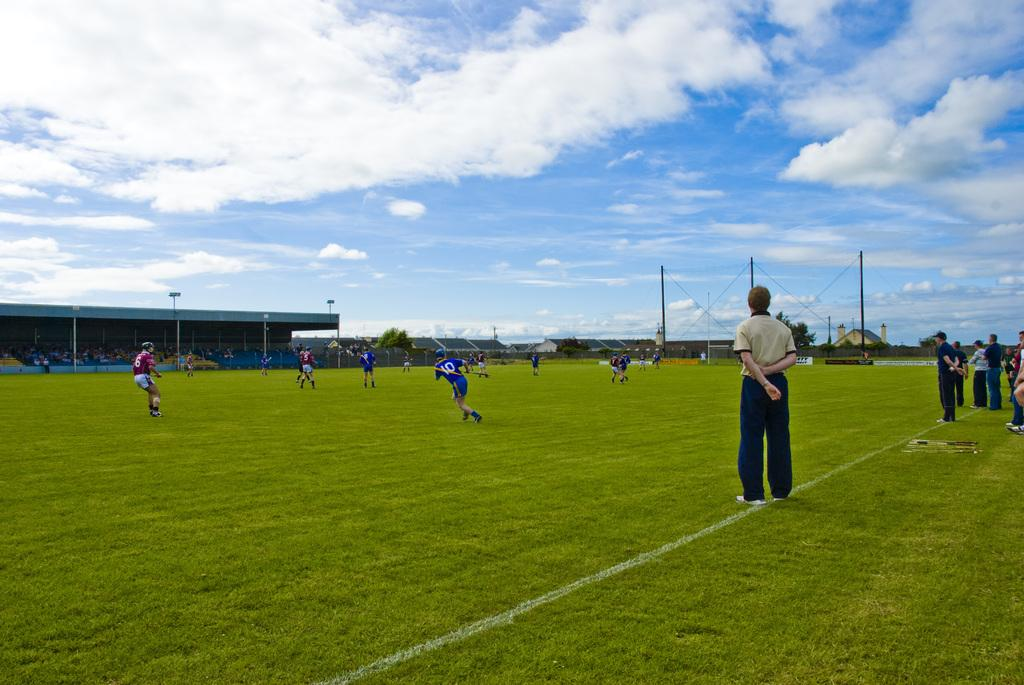What activity are the people in the image engaged in? People are playing a sport in the image. What type of surface is visible at the bottom of the image? There is grass at the bottom of the image. Can you describe the position of the person in the image? There is a person standing in the image. What is visible at the top of the image? The sky is visible at the top of the image. What can be seen in the sky in the image? Clouds are present in the sky. What type of cookware is being used by the person holding a rifle in the image? There is no person holding a rifle or using cookware in the image. 